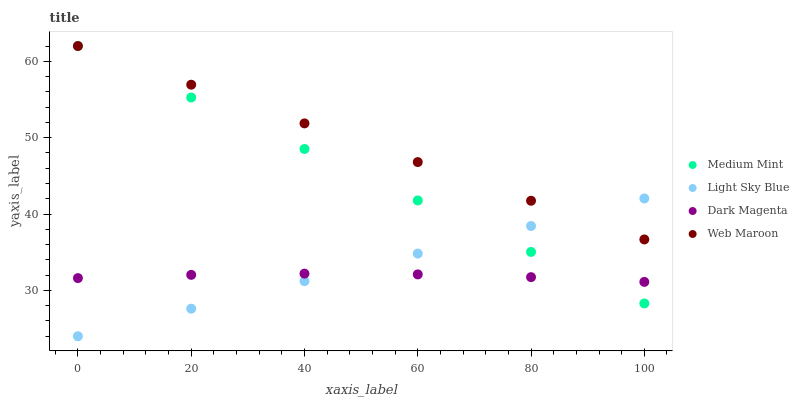Does Dark Magenta have the minimum area under the curve?
Answer yes or no. Yes. Does Web Maroon have the maximum area under the curve?
Answer yes or no. Yes. Does Light Sky Blue have the minimum area under the curve?
Answer yes or no. No. Does Light Sky Blue have the maximum area under the curve?
Answer yes or no. No. Is Light Sky Blue the smoothest?
Answer yes or no. Yes. Is Dark Magenta the roughest?
Answer yes or no. Yes. Is Web Maroon the smoothest?
Answer yes or no. No. Is Web Maroon the roughest?
Answer yes or no. No. Does Light Sky Blue have the lowest value?
Answer yes or no. Yes. Does Web Maroon have the lowest value?
Answer yes or no. No. Does Web Maroon have the highest value?
Answer yes or no. Yes. Does Light Sky Blue have the highest value?
Answer yes or no. No. Is Dark Magenta less than Web Maroon?
Answer yes or no. Yes. Is Web Maroon greater than Dark Magenta?
Answer yes or no. Yes. Does Medium Mint intersect Web Maroon?
Answer yes or no. Yes. Is Medium Mint less than Web Maroon?
Answer yes or no. No. Is Medium Mint greater than Web Maroon?
Answer yes or no. No. Does Dark Magenta intersect Web Maroon?
Answer yes or no. No. 